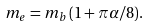<formula> <loc_0><loc_0><loc_500><loc_500>m _ { e } = m _ { b } \, ( 1 + \pi \alpha / 8 ) .</formula> 